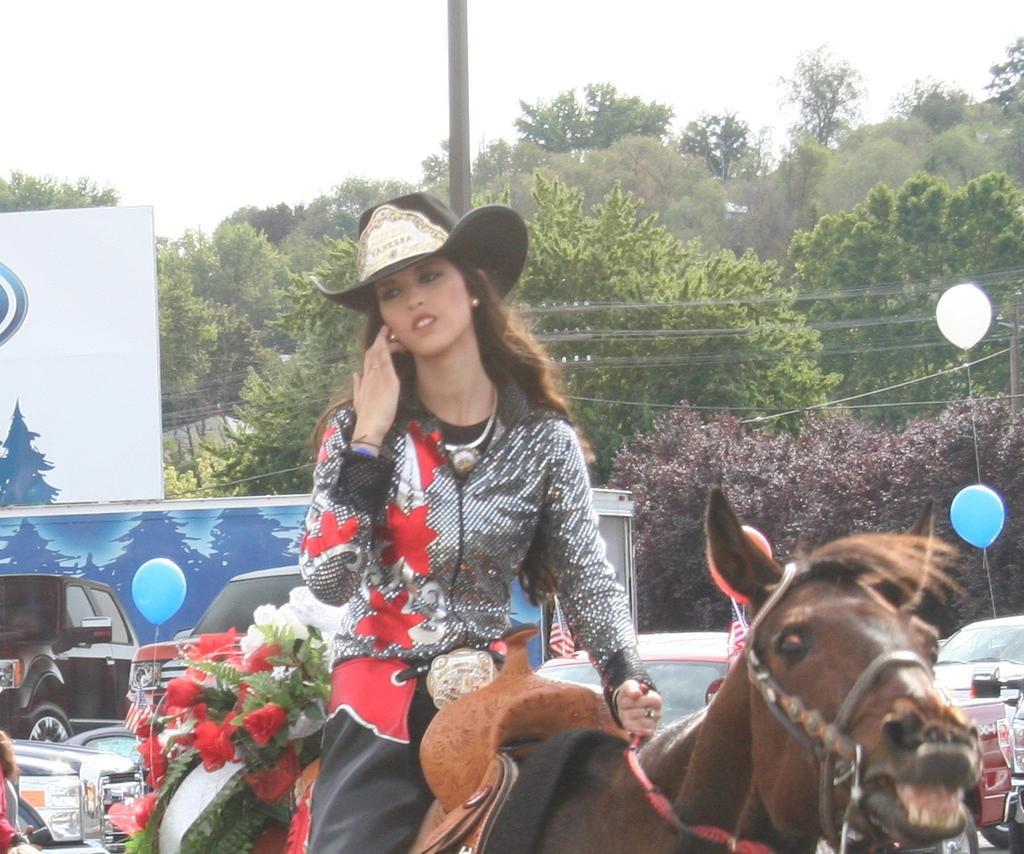Can you describe this image briefly? At the top we can see sky. These are trees. Here we can see one woman sitting on horse wearing hat and riding. These are flowers. We can see vehicles on the road. These are balloons in white and blue colour. 